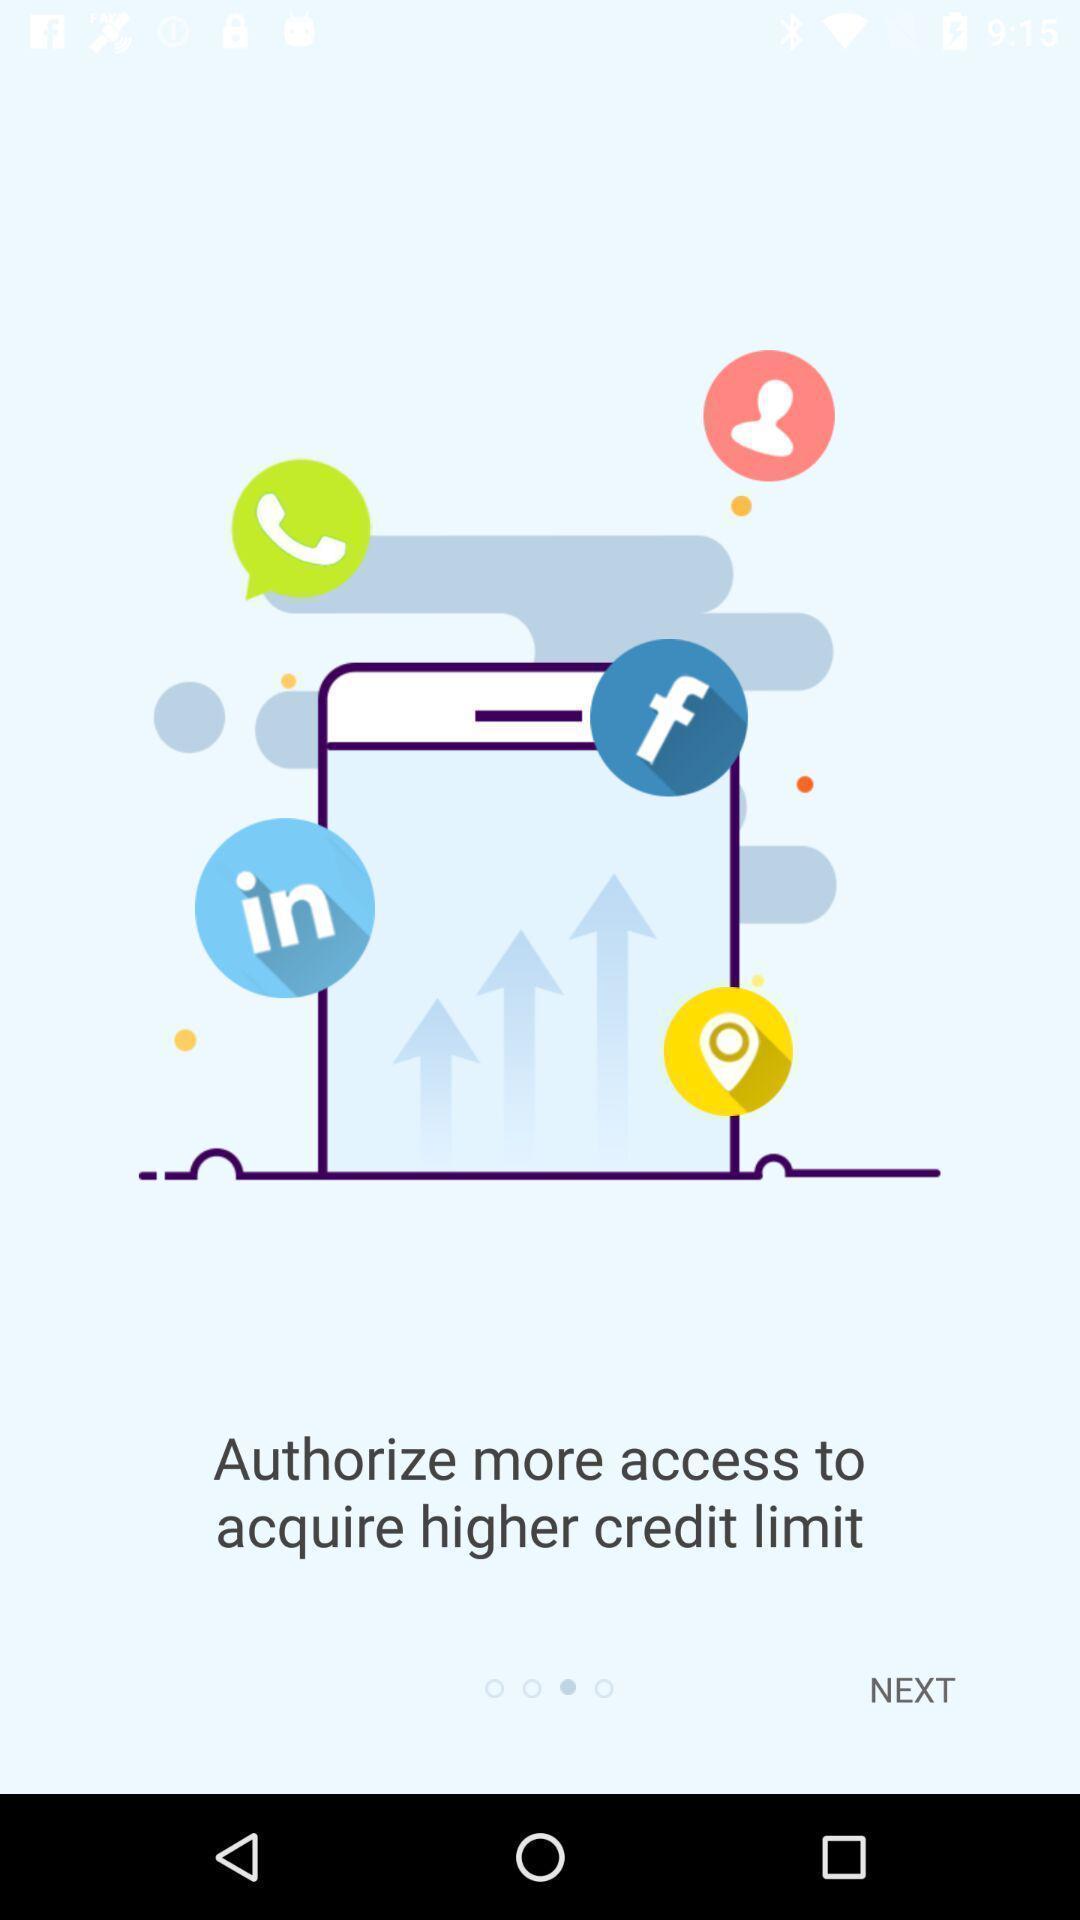Tell me about the visual elements in this screen capture. Welcome page. 